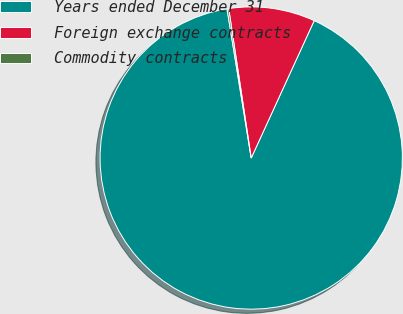Convert chart. <chart><loc_0><loc_0><loc_500><loc_500><pie_chart><fcel>Years ended December 31<fcel>Foreign exchange contracts<fcel>Commodity contracts<nl><fcel>90.6%<fcel>9.22%<fcel>0.18%<nl></chart> 